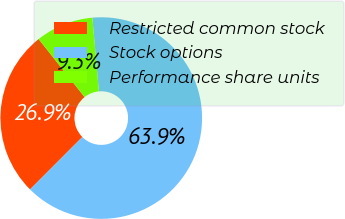Convert chart to OTSL. <chart><loc_0><loc_0><loc_500><loc_500><pie_chart><fcel>Restricted common stock<fcel>Stock options<fcel>Performance share units<nl><fcel>26.85%<fcel>63.89%<fcel>9.26%<nl></chart> 